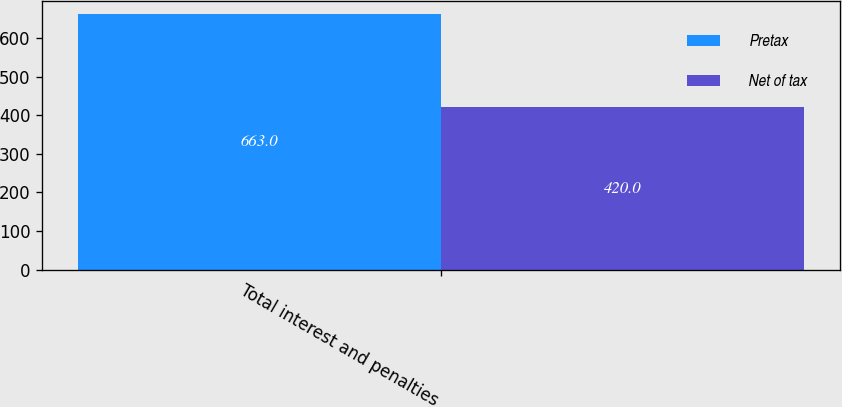Convert chart. <chart><loc_0><loc_0><loc_500><loc_500><stacked_bar_chart><ecel><fcel>Total interest and penalties<nl><fcel>Pretax<fcel>663<nl><fcel>Net of tax<fcel>420<nl></chart> 